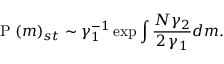<formula> <loc_0><loc_0><loc_500><loc_500>P ( m ) _ { s t } \sim \gamma _ { 1 } ^ { - 1 } \exp \int \frac { N \gamma _ { 2 } } { 2 \, \gamma _ { 1 } } d m .</formula> 